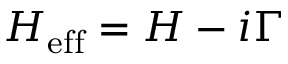<formula> <loc_0><loc_0><loc_500><loc_500>H _ { e f f } = H - i \Gamma</formula> 